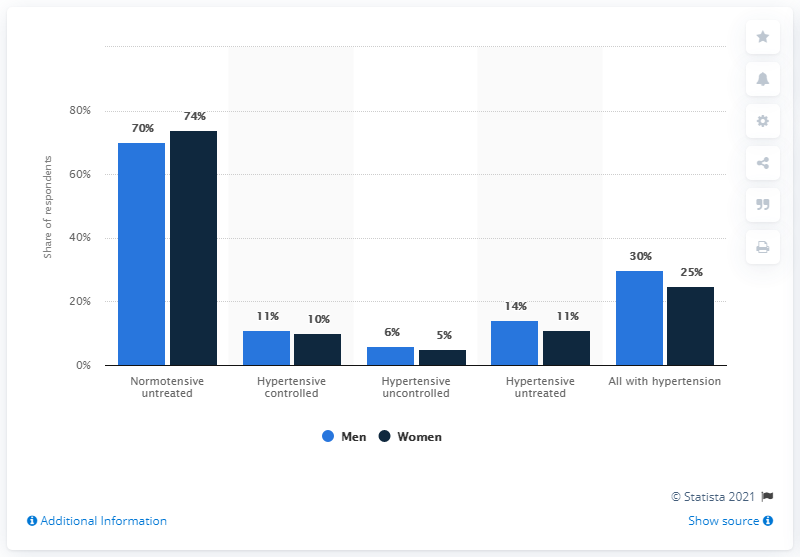List a handful of essential elements in this visual. The study found a difference of 5% among men and women with hypertension. Which is the most important factor among all? Normotensive untreated. 